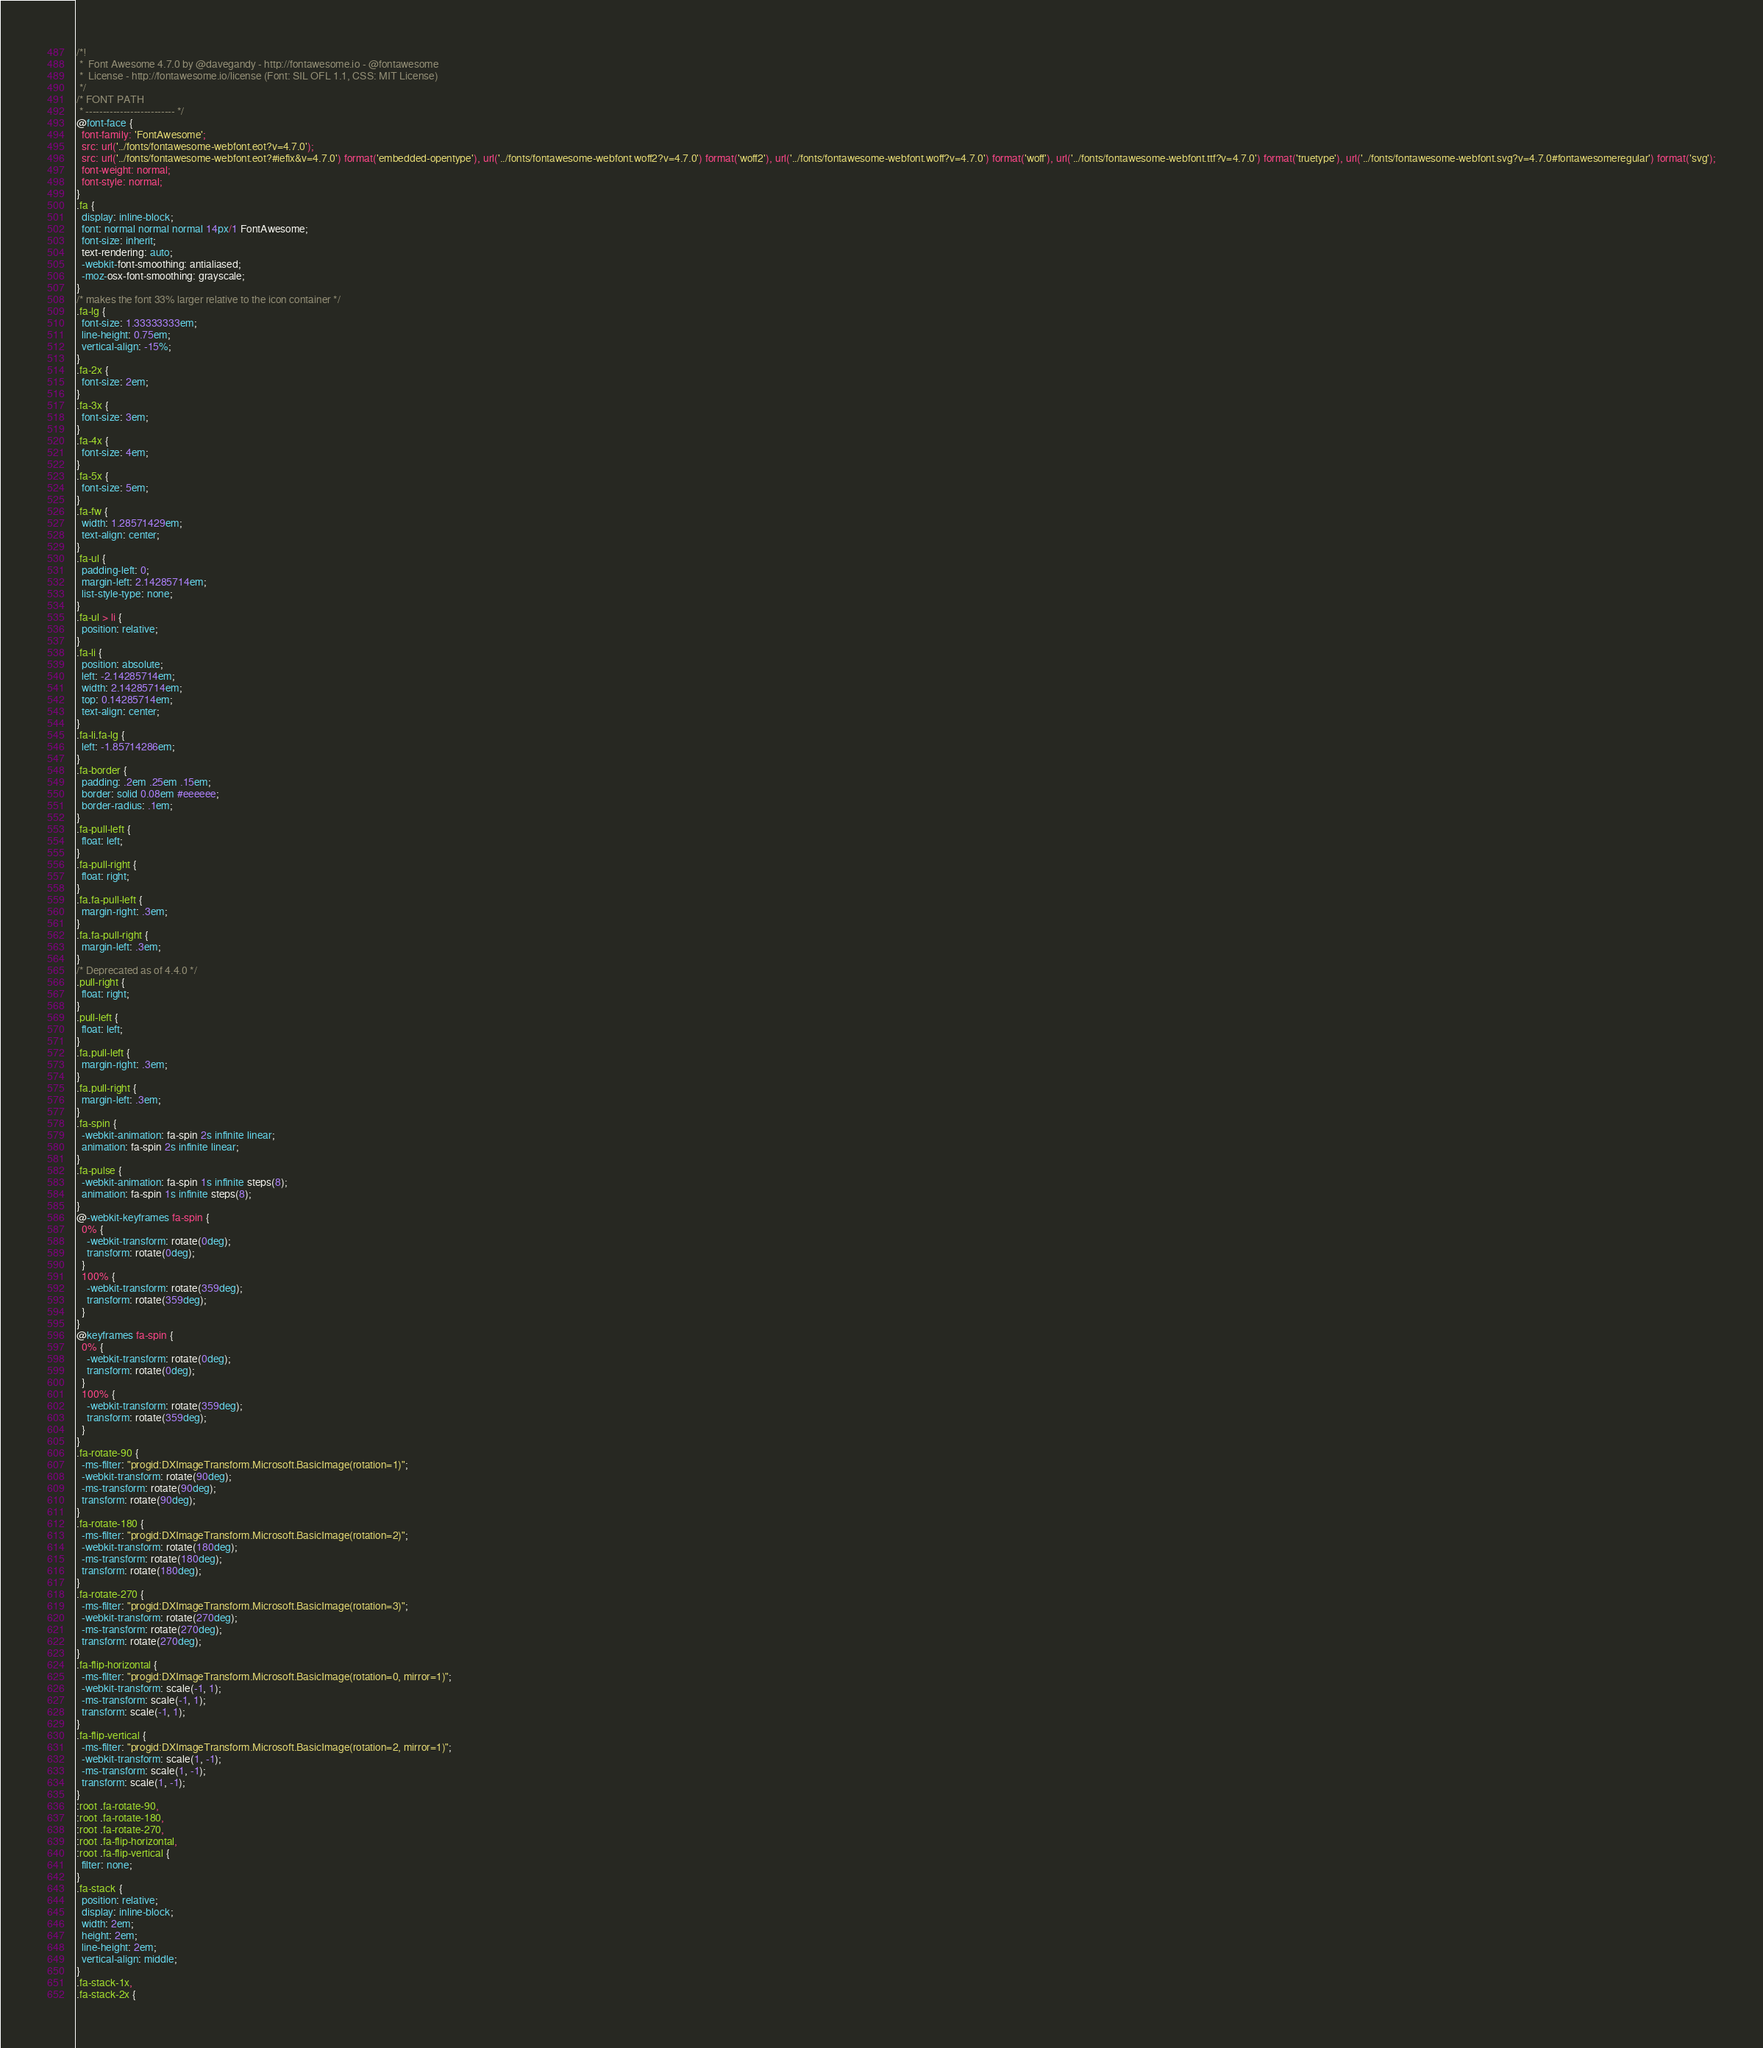<code> <loc_0><loc_0><loc_500><loc_500><_CSS_>/*!
 *  Font Awesome 4.7.0 by @davegandy - http://fontawesome.io - @fontawesome
 *  License - http://fontawesome.io/license (Font: SIL OFL 1.1, CSS: MIT License)
 */
/* FONT PATH
 * -------------------------- */
@font-face {
  font-family: 'FontAwesome';
  src: url('../fonts/fontawesome-webfont.eot?v=4.7.0');
  src: url('../fonts/fontawesome-webfont.eot?#iefix&v=4.7.0') format('embedded-opentype'), url('../fonts/fontawesome-webfont.woff2?v=4.7.0') format('woff2'), url('../fonts/fontawesome-webfont.woff?v=4.7.0') format('woff'), url('../fonts/fontawesome-webfont.ttf?v=4.7.0') format('truetype'), url('../fonts/fontawesome-webfont.svg?v=4.7.0#fontawesomeregular') format('svg');
  font-weight: normal;
  font-style: normal;
}
.fa {
  display: inline-block;
  font: normal normal normal 14px/1 FontAwesome;
  font-size: inherit;
  text-rendering: auto;
  -webkit-font-smoothing: antialiased;
  -moz-osx-font-smoothing: grayscale;
}
/* makes the font 33% larger relative to the icon container */
.fa-lg {
  font-size: 1.33333333em;
  line-height: 0.75em;
  vertical-align: -15%;
}
.fa-2x {
  font-size: 2em;
}
.fa-3x {
  font-size: 3em;
}
.fa-4x {
  font-size: 4em;
}
.fa-5x {
  font-size: 5em;
}
.fa-fw {
  width: 1.28571429em;
  text-align: center;
}
.fa-ul {
  padding-left: 0;
  margin-left: 2.14285714em;
  list-style-type: none;
}
.fa-ul > li {
  position: relative;
}
.fa-li {
  position: absolute;
  left: -2.14285714em;
  width: 2.14285714em;
  top: 0.14285714em;
  text-align: center;
}
.fa-li.fa-lg {
  left: -1.85714286em;
}
.fa-border {
  padding: .2em .25em .15em;
  border: solid 0.08em #eeeeee;
  border-radius: .1em;
}
.fa-pull-left {
  float: left;
}
.fa-pull-right {
  float: right;
}
.fa.fa-pull-left {
  margin-right: .3em;
}
.fa.fa-pull-right {
  margin-left: .3em;
}
/* Deprecated as of 4.4.0 */
.pull-right {
  float: right;
}
.pull-left {
  float: left;
}
.fa.pull-left {
  margin-right: .3em;
}
.fa.pull-right {
  margin-left: .3em;
}
.fa-spin {
  -webkit-animation: fa-spin 2s infinite linear;
  animation: fa-spin 2s infinite linear;
}
.fa-pulse {
  -webkit-animation: fa-spin 1s infinite steps(8);
  animation: fa-spin 1s infinite steps(8);
}
@-webkit-keyframes fa-spin {
  0% {
    -webkit-transform: rotate(0deg);
    transform: rotate(0deg);
  }
  100% {
    -webkit-transform: rotate(359deg);
    transform: rotate(359deg);
  }
}
@keyframes fa-spin {
  0% {
    -webkit-transform: rotate(0deg);
    transform: rotate(0deg);
  }
  100% {
    -webkit-transform: rotate(359deg);
    transform: rotate(359deg);
  }
}
.fa-rotate-90 {
  -ms-filter: "progid:DXImageTransform.Microsoft.BasicImage(rotation=1)";
  -webkit-transform: rotate(90deg);
  -ms-transform: rotate(90deg);
  transform: rotate(90deg);
}
.fa-rotate-180 {
  -ms-filter: "progid:DXImageTransform.Microsoft.BasicImage(rotation=2)";
  -webkit-transform: rotate(180deg);
  -ms-transform: rotate(180deg);
  transform: rotate(180deg);
}
.fa-rotate-270 {
  -ms-filter: "progid:DXImageTransform.Microsoft.BasicImage(rotation=3)";
  -webkit-transform: rotate(270deg);
  -ms-transform: rotate(270deg);
  transform: rotate(270deg);
}
.fa-flip-horizontal {
  -ms-filter: "progid:DXImageTransform.Microsoft.BasicImage(rotation=0, mirror=1)";
  -webkit-transform: scale(-1, 1);
  -ms-transform: scale(-1, 1);
  transform: scale(-1, 1);
}
.fa-flip-vertical {
  -ms-filter: "progid:DXImageTransform.Microsoft.BasicImage(rotation=2, mirror=1)";
  -webkit-transform: scale(1, -1);
  -ms-transform: scale(1, -1);
  transform: scale(1, -1);
}
:root .fa-rotate-90,
:root .fa-rotate-180,
:root .fa-rotate-270,
:root .fa-flip-horizontal,
:root .fa-flip-vertical {
  filter: none;
}
.fa-stack {
  position: relative;
  display: inline-block;
  width: 2em;
  height: 2em;
  line-height: 2em;
  vertical-align: middle;
}
.fa-stack-1x,
.fa-stack-2x {</code> 